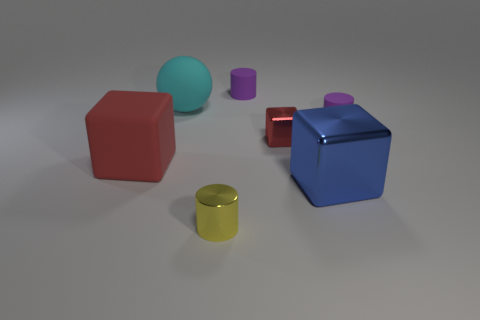Add 1 small red metal things. How many objects exist? 8 Subtract all blocks. How many objects are left? 4 Add 6 big cyan rubber objects. How many big cyan rubber objects exist? 7 Subtract 1 blue blocks. How many objects are left? 6 Subtract all brown cylinders. Subtract all tiny blocks. How many objects are left? 6 Add 3 large metal cubes. How many large metal cubes are left? 4 